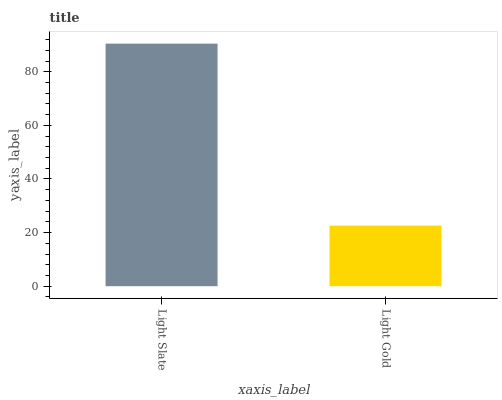Is Light Gold the minimum?
Answer yes or no. Yes. Is Light Slate the maximum?
Answer yes or no. Yes. Is Light Gold the maximum?
Answer yes or no. No. Is Light Slate greater than Light Gold?
Answer yes or no. Yes. Is Light Gold less than Light Slate?
Answer yes or no. Yes. Is Light Gold greater than Light Slate?
Answer yes or no. No. Is Light Slate less than Light Gold?
Answer yes or no. No. Is Light Slate the high median?
Answer yes or no. Yes. Is Light Gold the low median?
Answer yes or no. Yes. Is Light Gold the high median?
Answer yes or no. No. Is Light Slate the low median?
Answer yes or no. No. 